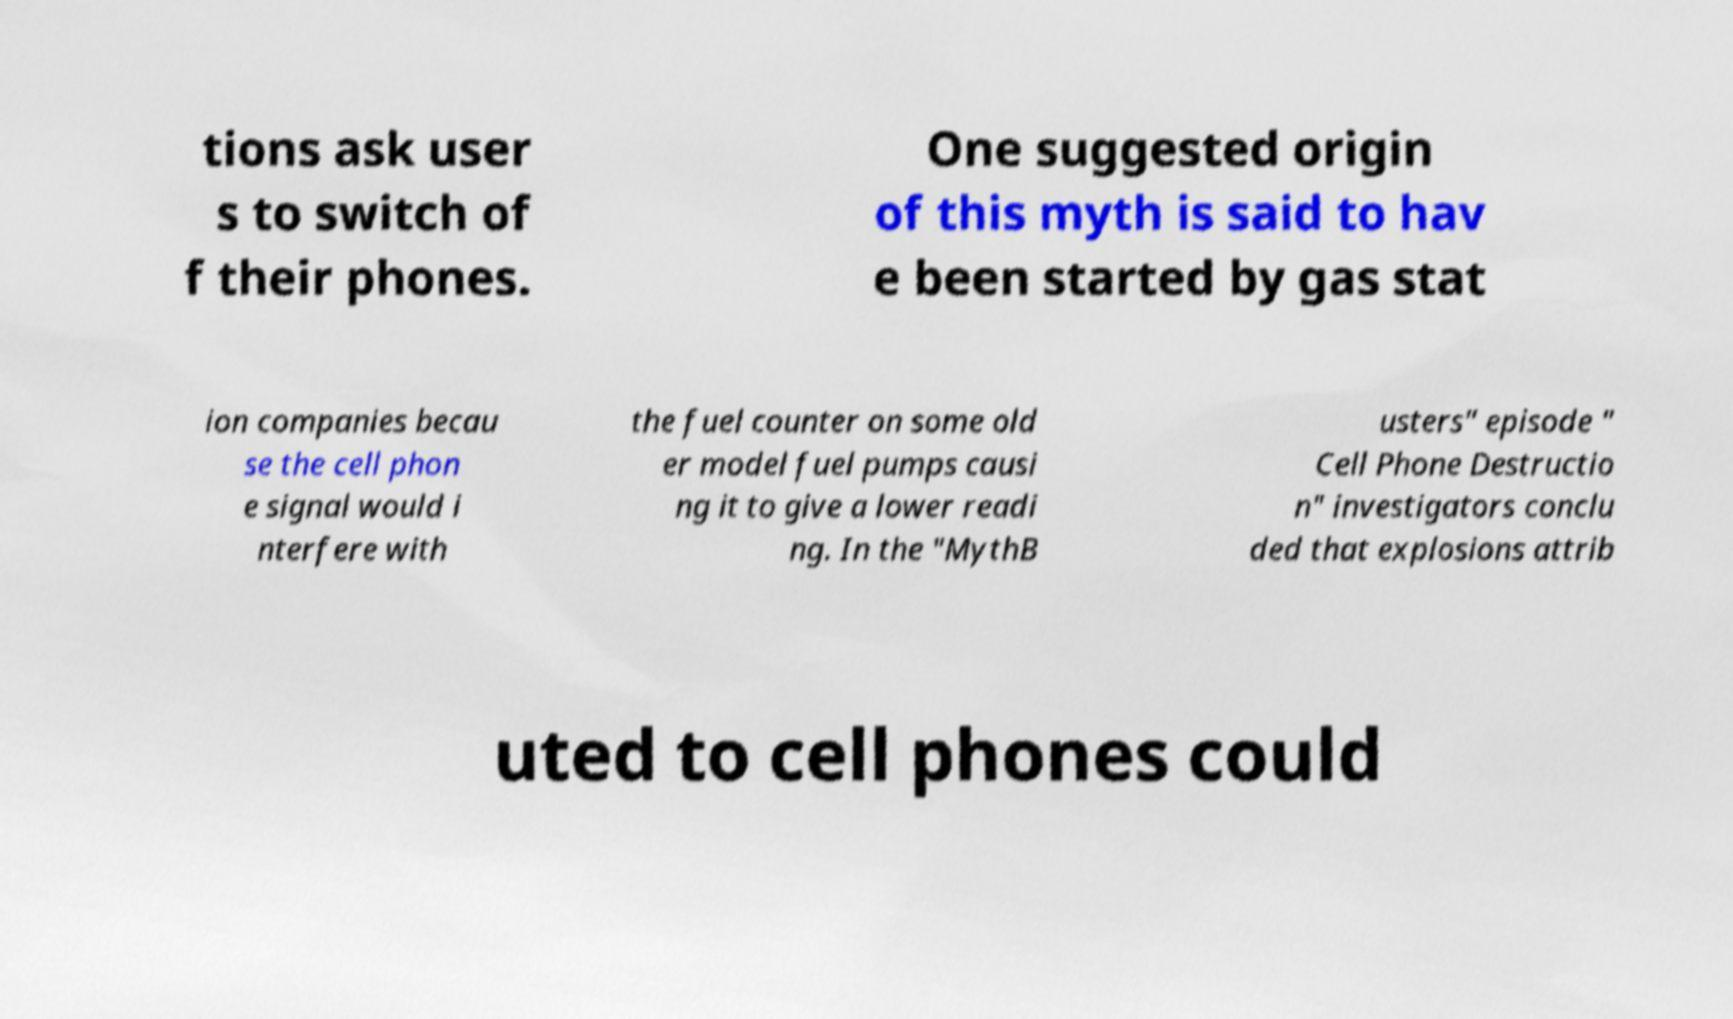Could you assist in decoding the text presented in this image and type it out clearly? tions ask user s to switch of f their phones. One suggested origin of this myth is said to hav e been started by gas stat ion companies becau se the cell phon e signal would i nterfere with the fuel counter on some old er model fuel pumps causi ng it to give a lower readi ng. In the "MythB usters" episode " Cell Phone Destructio n" investigators conclu ded that explosions attrib uted to cell phones could 